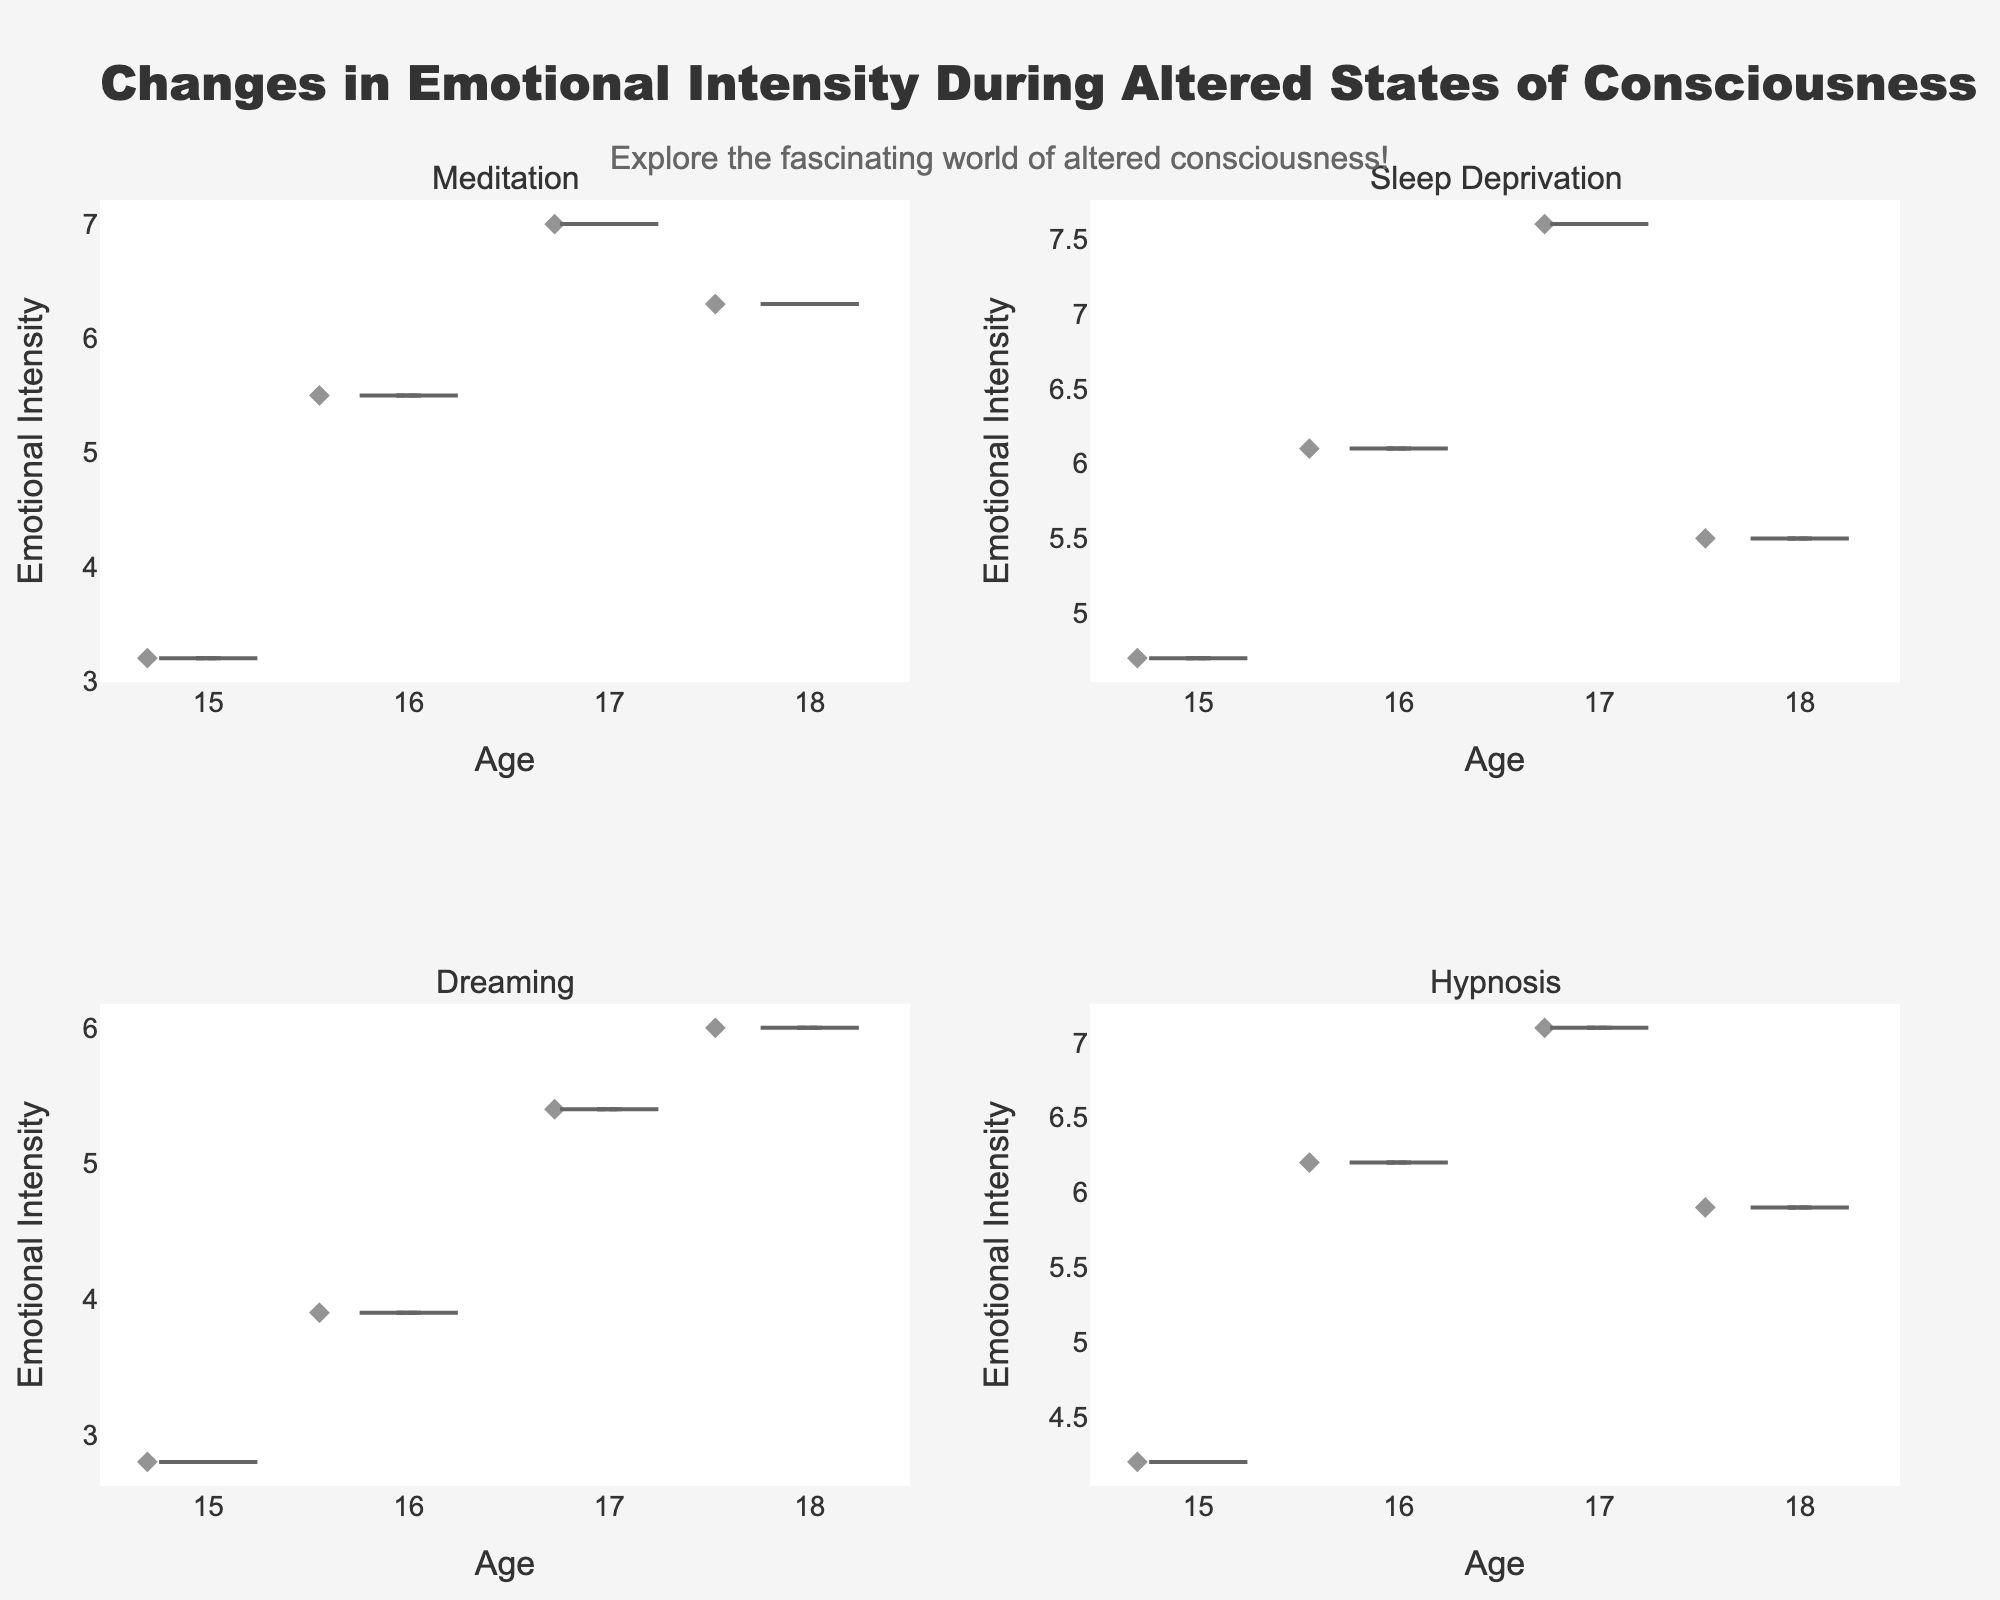What's the title of the figure? The title is located at the top of the figure and is typically written in larger and bold font to be easily visible. It summarizes the overall topic of the visual representation.
Answer: Changes in Emotional Intensity During Altered States of Consciousness What is the age range represented on the x-axis? By looking at the x-axis labels for each subplot, we can see that the tick marks indicate a range of ages.
Answer: 15 to 18 What color represents the 'Meditation' altered state? Each altered state is represented by a different color in the density plots. By identifying the color associated with the 'Meditation' label, we can answer this question.
Answer: Red Which altered state shows the highest emotional intensity overall? To determine which altered state shows the highest emotional intensity, observe the highest points on the y-axis across all subplots.
Answer: Sleep Deprivation What is the median emotional intensity for 'Dreaming'? The median value is usually represented by a horizontal line inside the box of the violin plot. By looking closely at the 'Dreaming' subplot, we can identify this value.
Answer: 4.65 Compare the emotional intensity of teenagers aged 18 during 'Meditation' and 'Hypnosis.' Which is higher? To compare the emotional intensities, we look at the points and the density in the respective subplots for age 18. By observing the y-coordinates, we can determine which state has a higher emotional intensity.
Answer: Meditation Between which ages does 'Hypnosis' show the most variation in emotional intensity? Variation can be estimated by examining the spread and shape of the violin plot. The more stretched or spread out the plot is at different ages, the more variation there is.
Answer: 16 and 17 How does the emotional intensity change with age during 'Sleep Deprivation'? By examining the 'Sleep Deprivation' subplot and looking at the trend from ages 15 to 18, we can infer whether the intensity increases, decreases, or remains the same.
Answer: Increases What's the average emotional intensity for 'Meditation' for teenagers aged 15 and 16? To find the average, we add the emotional intensities for ages 15 and 16 for 'Meditation' and then divide by 2. (3.2 + 5.5) / 2 = 4.35
Answer: 4.35 Which altered state has the lowest emotional intensity for the age of 15? By identifying the smallest y-values in the subplots for each altered state at age 15, we can determine the lowest intensity.
Answer: Dreaming 